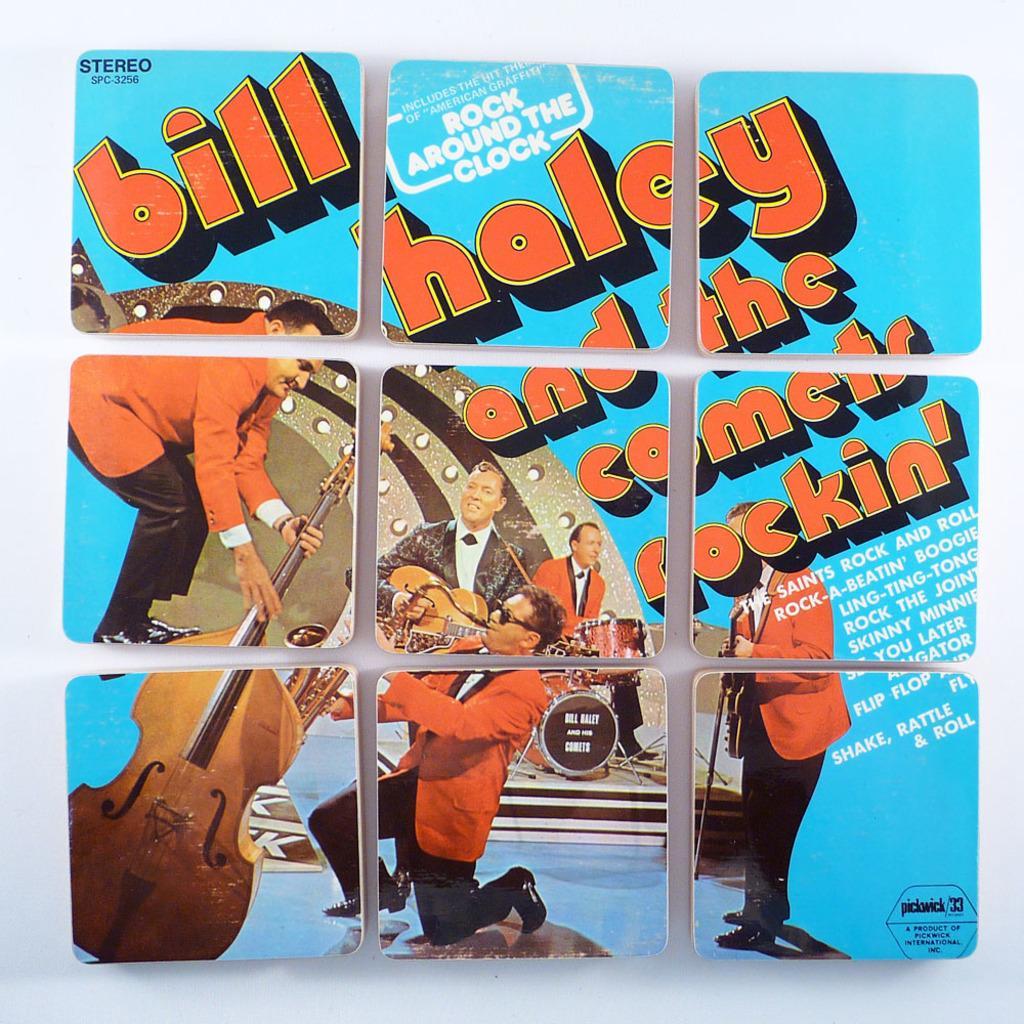Could you give a brief overview of what you see in this image? In this image there is a poster which is divided into nine blocks. In the poster we can see that there are few people who are playing the musical instruments. On the right side there is some text. 